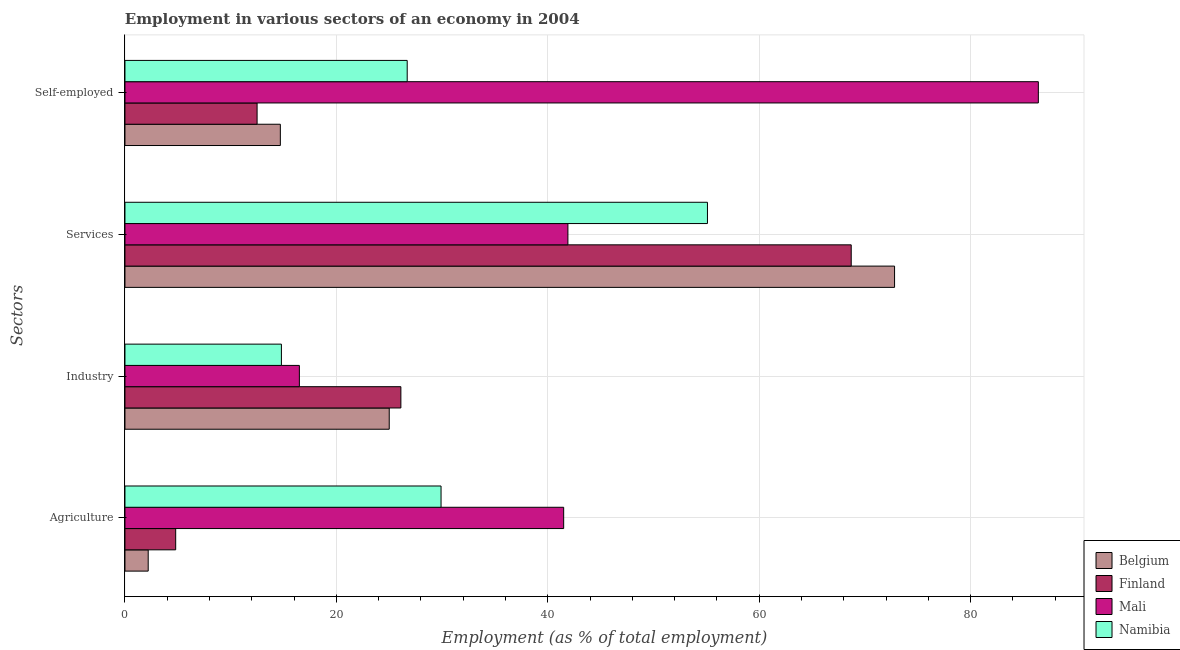How many groups of bars are there?
Make the answer very short. 4. Are the number of bars on each tick of the Y-axis equal?
Keep it short and to the point. Yes. How many bars are there on the 2nd tick from the top?
Ensure brevity in your answer.  4. How many bars are there on the 2nd tick from the bottom?
Ensure brevity in your answer.  4. What is the label of the 2nd group of bars from the top?
Offer a very short reply. Services. What is the percentage of self employed workers in Mali?
Give a very brief answer. 86.4. Across all countries, what is the maximum percentage of workers in agriculture?
Your answer should be very brief. 41.5. Across all countries, what is the minimum percentage of workers in industry?
Give a very brief answer. 14.8. In which country was the percentage of self employed workers maximum?
Your answer should be very brief. Mali. What is the total percentage of workers in agriculture in the graph?
Provide a succinct answer. 78.4. What is the difference between the percentage of workers in industry in Belgium and that in Finland?
Your answer should be compact. -1.1. What is the difference between the percentage of self employed workers in Namibia and the percentage of workers in agriculture in Belgium?
Your response must be concise. 24.5. What is the average percentage of self employed workers per country?
Provide a short and direct response. 35.08. What is the difference between the percentage of workers in agriculture and percentage of workers in services in Mali?
Give a very brief answer. -0.4. In how many countries, is the percentage of workers in services greater than 84 %?
Give a very brief answer. 0. What is the ratio of the percentage of workers in services in Finland to that in Mali?
Provide a short and direct response. 1.64. Is the difference between the percentage of workers in agriculture in Belgium and Finland greater than the difference between the percentage of workers in services in Belgium and Finland?
Offer a very short reply. No. What is the difference between the highest and the second highest percentage of workers in agriculture?
Your answer should be very brief. 11.6. What is the difference between the highest and the lowest percentage of workers in agriculture?
Give a very brief answer. 39.3. In how many countries, is the percentage of self employed workers greater than the average percentage of self employed workers taken over all countries?
Make the answer very short. 1. What does the 2nd bar from the top in Self-employed represents?
Your response must be concise. Mali. What does the 3rd bar from the bottom in Industry represents?
Keep it short and to the point. Mali. Is it the case that in every country, the sum of the percentage of workers in agriculture and percentage of workers in industry is greater than the percentage of workers in services?
Your response must be concise. No. How many bars are there?
Your answer should be very brief. 16. Are all the bars in the graph horizontal?
Keep it short and to the point. Yes. How many countries are there in the graph?
Your response must be concise. 4. What is the difference between two consecutive major ticks on the X-axis?
Ensure brevity in your answer.  20. Are the values on the major ticks of X-axis written in scientific E-notation?
Make the answer very short. No. Does the graph contain any zero values?
Give a very brief answer. No. Does the graph contain grids?
Ensure brevity in your answer.  Yes. How are the legend labels stacked?
Ensure brevity in your answer.  Vertical. What is the title of the graph?
Keep it short and to the point. Employment in various sectors of an economy in 2004. Does "Bahrain" appear as one of the legend labels in the graph?
Your answer should be very brief. No. What is the label or title of the X-axis?
Keep it short and to the point. Employment (as % of total employment). What is the label or title of the Y-axis?
Provide a short and direct response. Sectors. What is the Employment (as % of total employment) in Belgium in Agriculture?
Your answer should be compact. 2.2. What is the Employment (as % of total employment) in Finland in Agriculture?
Provide a short and direct response. 4.8. What is the Employment (as % of total employment) of Mali in Agriculture?
Your response must be concise. 41.5. What is the Employment (as % of total employment) of Namibia in Agriculture?
Your response must be concise. 29.9. What is the Employment (as % of total employment) in Finland in Industry?
Your answer should be very brief. 26.1. What is the Employment (as % of total employment) in Mali in Industry?
Keep it short and to the point. 16.5. What is the Employment (as % of total employment) in Namibia in Industry?
Ensure brevity in your answer.  14.8. What is the Employment (as % of total employment) of Belgium in Services?
Your response must be concise. 72.8. What is the Employment (as % of total employment) in Finland in Services?
Provide a succinct answer. 68.7. What is the Employment (as % of total employment) in Mali in Services?
Provide a short and direct response. 41.9. What is the Employment (as % of total employment) in Namibia in Services?
Provide a succinct answer. 55.1. What is the Employment (as % of total employment) of Belgium in Self-employed?
Offer a terse response. 14.7. What is the Employment (as % of total employment) of Finland in Self-employed?
Your answer should be very brief. 12.5. What is the Employment (as % of total employment) in Mali in Self-employed?
Give a very brief answer. 86.4. What is the Employment (as % of total employment) of Namibia in Self-employed?
Give a very brief answer. 26.7. Across all Sectors, what is the maximum Employment (as % of total employment) in Belgium?
Provide a succinct answer. 72.8. Across all Sectors, what is the maximum Employment (as % of total employment) of Finland?
Provide a succinct answer. 68.7. Across all Sectors, what is the maximum Employment (as % of total employment) in Mali?
Provide a short and direct response. 86.4. Across all Sectors, what is the maximum Employment (as % of total employment) of Namibia?
Keep it short and to the point. 55.1. Across all Sectors, what is the minimum Employment (as % of total employment) of Belgium?
Provide a succinct answer. 2.2. Across all Sectors, what is the minimum Employment (as % of total employment) of Finland?
Your response must be concise. 4.8. Across all Sectors, what is the minimum Employment (as % of total employment) in Namibia?
Offer a terse response. 14.8. What is the total Employment (as % of total employment) of Belgium in the graph?
Provide a short and direct response. 114.7. What is the total Employment (as % of total employment) of Finland in the graph?
Offer a terse response. 112.1. What is the total Employment (as % of total employment) in Mali in the graph?
Provide a succinct answer. 186.3. What is the total Employment (as % of total employment) in Namibia in the graph?
Provide a succinct answer. 126.5. What is the difference between the Employment (as % of total employment) of Belgium in Agriculture and that in Industry?
Ensure brevity in your answer.  -22.8. What is the difference between the Employment (as % of total employment) of Finland in Agriculture and that in Industry?
Your answer should be compact. -21.3. What is the difference between the Employment (as % of total employment) in Mali in Agriculture and that in Industry?
Give a very brief answer. 25. What is the difference between the Employment (as % of total employment) of Belgium in Agriculture and that in Services?
Ensure brevity in your answer.  -70.6. What is the difference between the Employment (as % of total employment) of Finland in Agriculture and that in Services?
Ensure brevity in your answer.  -63.9. What is the difference between the Employment (as % of total employment) in Namibia in Agriculture and that in Services?
Keep it short and to the point. -25.2. What is the difference between the Employment (as % of total employment) in Mali in Agriculture and that in Self-employed?
Make the answer very short. -44.9. What is the difference between the Employment (as % of total employment) of Belgium in Industry and that in Services?
Offer a terse response. -47.8. What is the difference between the Employment (as % of total employment) of Finland in Industry and that in Services?
Offer a very short reply. -42.6. What is the difference between the Employment (as % of total employment) of Mali in Industry and that in Services?
Your response must be concise. -25.4. What is the difference between the Employment (as % of total employment) of Namibia in Industry and that in Services?
Your answer should be compact. -40.3. What is the difference between the Employment (as % of total employment) of Mali in Industry and that in Self-employed?
Your response must be concise. -69.9. What is the difference between the Employment (as % of total employment) in Namibia in Industry and that in Self-employed?
Your response must be concise. -11.9. What is the difference between the Employment (as % of total employment) of Belgium in Services and that in Self-employed?
Make the answer very short. 58.1. What is the difference between the Employment (as % of total employment) in Finland in Services and that in Self-employed?
Your answer should be very brief. 56.2. What is the difference between the Employment (as % of total employment) in Mali in Services and that in Self-employed?
Offer a very short reply. -44.5. What is the difference between the Employment (as % of total employment) in Namibia in Services and that in Self-employed?
Your answer should be compact. 28.4. What is the difference between the Employment (as % of total employment) in Belgium in Agriculture and the Employment (as % of total employment) in Finland in Industry?
Ensure brevity in your answer.  -23.9. What is the difference between the Employment (as % of total employment) of Belgium in Agriculture and the Employment (as % of total employment) of Mali in Industry?
Provide a succinct answer. -14.3. What is the difference between the Employment (as % of total employment) of Belgium in Agriculture and the Employment (as % of total employment) of Namibia in Industry?
Your answer should be very brief. -12.6. What is the difference between the Employment (as % of total employment) in Finland in Agriculture and the Employment (as % of total employment) in Mali in Industry?
Keep it short and to the point. -11.7. What is the difference between the Employment (as % of total employment) in Finland in Agriculture and the Employment (as % of total employment) in Namibia in Industry?
Offer a terse response. -10. What is the difference between the Employment (as % of total employment) in Mali in Agriculture and the Employment (as % of total employment) in Namibia in Industry?
Offer a very short reply. 26.7. What is the difference between the Employment (as % of total employment) in Belgium in Agriculture and the Employment (as % of total employment) in Finland in Services?
Make the answer very short. -66.5. What is the difference between the Employment (as % of total employment) in Belgium in Agriculture and the Employment (as % of total employment) in Mali in Services?
Provide a short and direct response. -39.7. What is the difference between the Employment (as % of total employment) in Belgium in Agriculture and the Employment (as % of total employment) in Namibia in Services?
Make the answer very short. -52.9. What is the difference between the Employment (as % of total employment) of Finland in Agriculture and the Employment (as % of total employment) of Mali in Services?
Your response must be concise. -37.1. What is the difference between the Employment (as % of total employment) of Finland in Agriculture and the Employment (as % of total employment) of Namibia in Services?
Your response must be concise. -50.3. What is the difference between the Employment (as % of total employment) in Belgium in Agriculture and the Employment (as % of total employment) in Mali in Self-employed?
Your answer should be very brief. -84.2. What is the difference between the Employment (as % of total employment) in Belgium in Agriculture and the Employment (as % of total employment) in Namibia in Self-employed?
Keep it short and to the point. -24.5. What is the difference between the Employment (as % of total employment) of Finland in Agriculture and the Employment (as % of total employment) of Mali in Self-employed?
Offer a terse response. -81.6. What is the difference between the Employment (as % of total employment) in Finland in Agriculture and the Employment (as % of total employment) in Namibia in Self-employed?
Your answer should be very brief. -21.9. What is the difference between the Employment (as % of total employment) of Mali in Agriculture and the Employment (as % of total employment) of Namibia in Self-employed?
Ensure brevity in your answer.  14.8. What is the difference between the Employment (as % of total employment) in Belgium in Industry and the Employment (as % of total employment) in Finland in Services?
Make the answer very short. -43.7. What is the difference between the Employment (as % of total employment) in Belgium in Industry and the Employment (as % of total employment) in Mali in Services?
Your answer should be compact. -16.9. What is the difference between the Employment (as % of total employment) in Belgium in Industry and the Employment (as % of total employment) in Namibia in Services?
Provide a short and direct response. -30.1. What is the difference between the Employment (as % of total employment) in Finland in Industry and the Employment (as % of total employment) in Mali in Services?
Provide a short and direct response. -15.8. What is the difference between the Employment (as % of total employment) of Finland in Industry and the Employment (as % of total employment) of Namibia in Services?
Your answer should be compact. -29. What is the difference between the Employment (as % of total employment) of Mali in Industry and the Employment (as % of total employment) of Namibia in Services?
Make the answer very short. -38.6. What is the difference between the Employment (as % of total employment) of Belgium in Industry and the Employment (as % of total employment) of Mali in Self-employed?
Your answer should be compact. -61.4. What is the difference between the Employment (as % of total employment) in Belgium in Industry and the Employment (as % of total employment) in Namibia in Self-employed?
Your response must be concise. -1.7. What is the difference between the Employment (as % of total employment) in Finland in Industry and the Employment (as % of total employment) in Mali in Self-employed?
Provide a succinct answer. -60.3. What is the difference between the Employment (as % of total employment) in Finland in Industry and the Employment (as % of total employment) in Namibia in Self-employed?
Your answer should be compact. -0.6. What is the difference between the Employment (as % of total employment) of Belgium in Services and the Employment (as % of total employment) of Finland in Self-employed?
Give a very brief answer. 60.3. What is the difference between the Employment (as % of total employment) in Belgium in Services and the Employment (as % of total employment) in Mali in Self-employed?
Make the answer very short. -13.6. What is the difference between the Employment (as % of total employment) of Belgium in Services and the Employment (as % of total employment) of Namibia in Self-employed?
Your answer should be very brief. 46.1. What is the difference between the Employment (as % of total employment) of Finland in Services and the Employment (as % of total employment) of Mali in Self-employed?
Your answer should be compact. -17.7. What is the difference between the Employment (as % of total employment) in Finland in Services and the Employment (as % of total employment) in Namibia in Self-employed?
Make the answer very short. 42. What is the difference between the Employment (as % of total employment) of Mali in Services and the Employment (as % of total employment) of Namibia in Self-employed?
Give a very brief answer. 15.2. What is the average Employment (as % of total employment) in Belgium per Sectors?
Offer a very short reply. 28.68. What is the average Employment (as % of total employment) in Finland per Sectors?
Ensure brevity in your answer.  28.02. What is the average Employment (as % of total employment) in Mali per Sectors?
Ensure brevity in your answer.  46.58. What is the average Employment (as % of total employment) in Namibia per Sectors?
Offer a terse response. 31.62. What is the difference between the Employment (as % of total employment) in Belgium and Employment (as % of total employment) in Finland in Agriculture?
Make the answer very short. -2.6. What is the difference between the Employment (as % of total employment) of Belgium and Employment (as % of total employment) of Mali in Agriculture?
Offer a terse response. -39.3. What is the difference between the Employment (as % of total employment) in Belgium and Employment (as % of total employment) in Namibia in Agriculture?
Keep it short and to the point. -27.7. What is the difference between the Employment (as % of total employment) in Finland and Employment (as % of total employment) in Mali in Agriculture?
Ensure brevity in your answer.  -36.7. What is the difference between the Employment (as % of total employment) in Finland and Employment (as % of total employment) in Namibia in Agriculture?
Provide a succinct answer. -25.1. What is the difference between the Employment (as % of total employment) of Mali and Employment (as % of total employment) of Namibia in Agriculture?
Ensure brevity in your answer.  11.6. What is the difference between the Employment (as % of total employment) in Belgium and Employment (as % of total employment) in Finland in Industry?
Offer a terse response. -1.1. What is the difference between the Employment (as % of total employment) of Belgium and Employment (as % of total employment) of Mali in Industry?
Your response must be concise. 8.5. What is the difference between the Employment (as % of total employment) in Finland and Employment (as % of total employment) in Mali in Industry?
Provide a succinct answer. 9.6. What is the difference between the Employment (as % of total employment) of Belgium and Employment (as % of total employment) of Finland in Services?
Make the answer very short. 4.1. What is the difference between the Employment (as % of total employment) in Belgium and Employment (as % of total employment) in Mali in Services?
Your answer should be compact. 30.9. What is the difference between the Employment (as % of total employment) in Belgium and Employment (as % of total employment) in Namibia in Services?
Make the answer very short. 17.7. What is the difference between the Employment (as % of total employment) in Finland and Employment (as % of total employment) in Mali in Services?
Keep it short and to the point. 26.8. What is the difference between the Employment (as % of total employment) of Belgium and Employment (as % of total employment) of Mali in Self-employed?
Make the answer very short. -71.7. What is the difference between the Employment (as % of total employment) of Finland and Employment (as % of total employment) of Mali in Self-employed?
Give a very brief answer. -73.9. What is the difference between the Employment (as % of total employment) in Mali and Employment (as % of total employment) in Namibia in Self-employed?
Provide a succinct answer. 59.7. What is the ratio of the Employment (as % of total employment) of Belgium in Agriculture to that in Industry?
Your response must be concise. 0.09. What is the ratio of the Employment (as % of total employment) of Finland in Agriculture to that in Industry?
Give a very brief answer. 0.18. What is the ratio of the Employment (as % of total employment) in Mali in Agriculture to that in Industry?
Your answer should be compact. 2.52. What is the ratio of the Employment (as % of total employment) of Namibia in Agriculture to that in Industry?
Provide a short and direct response. 2.02. What is the ratio of the Employment (as % of total employment) in Belgium in Agriculture to that in Services?
Provide a succinct answer. 0.03. What is the ratio of the Employment (as % of total employment) in Finland in Agriculture to that in Services?
Your answer should be compact. 0.07. What is the ratio of the Employment (as % of total employment) in Mali in Agriculture to that in Services?
Ensure brevity in your answer.  0.99. What is the ratio of the Employment (as % of total employment) of Namibia in Agriculture to that in Services?
Offer a terse response. 0.54. What is the ratio of the Employment (as % of total employment) of Belgium in Agriculture to that in Self-employed?
Offer a terse response. 0.15. What is the ratio of the Employment (as % of total employment) in Finland in Agriculture to that in Self-employed?
Give a very brief answer. 0.38. What is the ratio of the Employment (as % of total employment) in Mali in Agriculture to that in Self-employed?
Provide a succinct answer. 0.48. What is the ratio of the Employment (as % of total employment) of Namibia in Agriculture to that in Self-employed?
Your answer should be compact. 1.12. What is the ratio of the Employment (as % of total employment) of Belgium in Industry to that in Services?
Provide a succinct answer. 0.34. What is the ratio of the Employment (as % of total employment) in Finland in Industry to that in Services?
Offer a very short reply. 0.38. What is the ratio of the Employment (as % of total employment) of Mali in Industry to that in Services?
Your answer should be very brief. 0.39. What is the ratio of the Employment (as % of total employment) in Namibia in Industry to that in Services?
Provide a short and direct response. 0.27. What is the ratio of the Employment (as % of total employment) in Belgium in Industry to that in Self-employed?
Keep it short and to the point. 1.7. What is the ratio of the Employment (as % of total employment) in Finland in Industry to that in Self-employed?
Your answer should be compact. 2.09. What is the ratio of the Employment (as % of total employment) in Mali in Industry to that in Self-employed?
Provide a short and direct response. 0.19. What is the ratio of the Employment (as % of total employment) of Namibia in Industry to that in Self-employed?
Your response must be concise. 0.55. What is the ratio of the Employment (as % of total employment) in Belgium in Services to that in Self-employed?
Your answer should be compact. 4.95. What is the ratio of the Employment (as % of total employment) of Finland in Services to that in Self-employed?
Give a very brief answer. 5.5. What is the ratio of the Employment (as % of total employment) of Mali in Services to that in Self-employed?
Your answer should be compact. 0.48. What is the ratio of the Employment (as % of total employment) in Namibia in Services to that in Self-employed?
Make the answer very short. 2.06. What is the difference between the highest and the second highest Employment (as % of total employment) of Belgium?
Give a very brief answer. 47.8. What is the difference between the highest and the second highest Employment (as % of total employment) of Finland?
Give a very brief answer. 42.6. What is the difference between the highest and the second highest Employment (as % of total employment) of Mali?
Offer a very short reply. 44.5. What is the difference between the highest and the second highest Employment (as % of total employment) in Namibia?
Keep it short and to the point. 25.2. What is the difference between the highest and the lowest Employment (as % of total employment) in Belgium?
Your answer should be compact. 70.6. What is the difference between the highest and the lowest Employment (as % of total employment) of Finland?
Provide a short and direct response. 63.9. What is the difference between the highest and the lowest Employment (as % of total employment) of Mali?
Your answer should be compact. 69.9. What is the difference between the highest and the lowest Employment (as % of total employment) in Namibia?
Provide a succinct answer. 40.3. 